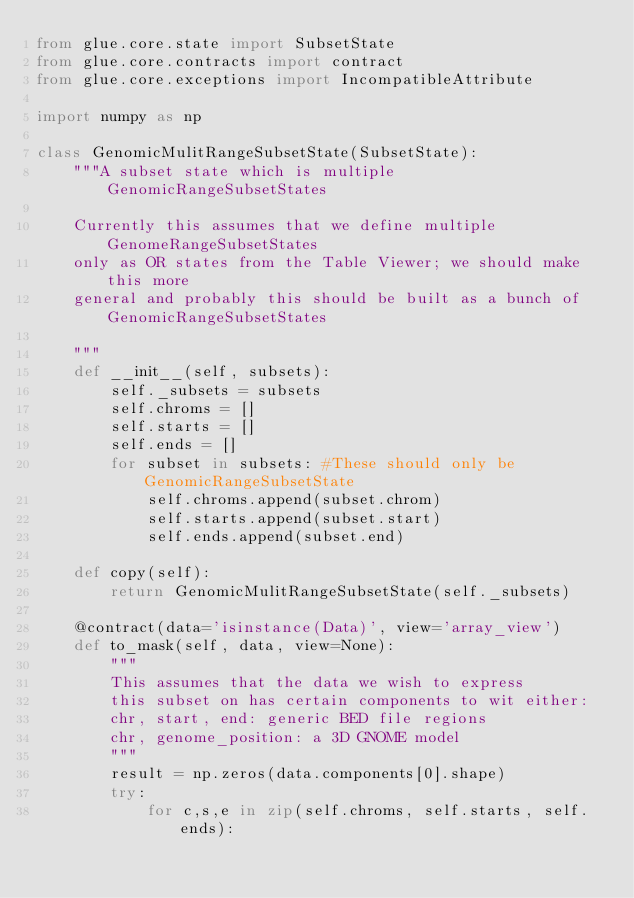Convert code to text. <code><loc_0><loc_0><loc_500><loc_500><_Python_>from glue.core.state import SubsetState
from glue.core.contracts import contract
from glue.core.exceptions import IncompatibleAttribute

import numpy as np

class GenomicMulitRangeSubsetState(SubsetState):
    """A subset state which is multiple GenomicRangeSubsetStates
    
    Currently this assumes that we define multiple GenomeRangeSubsetStates
    only as OR states from the Table Viewer; we should make this more
    general and probably this should be built as a bunch of GenomicRangeSubsetStates
    
    """
    def __init__(self, subsets):
        self._subsets = subsets
        self.chroms = []
        self.starts = []
        self.ends = []
        for subset in subsets: #These should only be GenomicRangeSubsetState
            self.chroms.append(subset.chrom)
            self.starts.append(subset.start)
            self.ends.append(subset.end)
            
    def copy(self):
        return GenomicMulitRangeSubsetState(self._subsets)
            
    @contract(data='isinstance(Data)', view='array_view')
    def to_mask(self, data, view=None):
        """
        This assumes that the data we wish to express
        this subset on has certain components to wit either:
        chr, start, end: generic BED file regions
        chr, genome_position: a 3D GNOME model
        """
        result = np.zeros(data.components[0].shape)
        try:
            for c,s,e in zip(self.chroms, self.starts, self.ends):</code> 